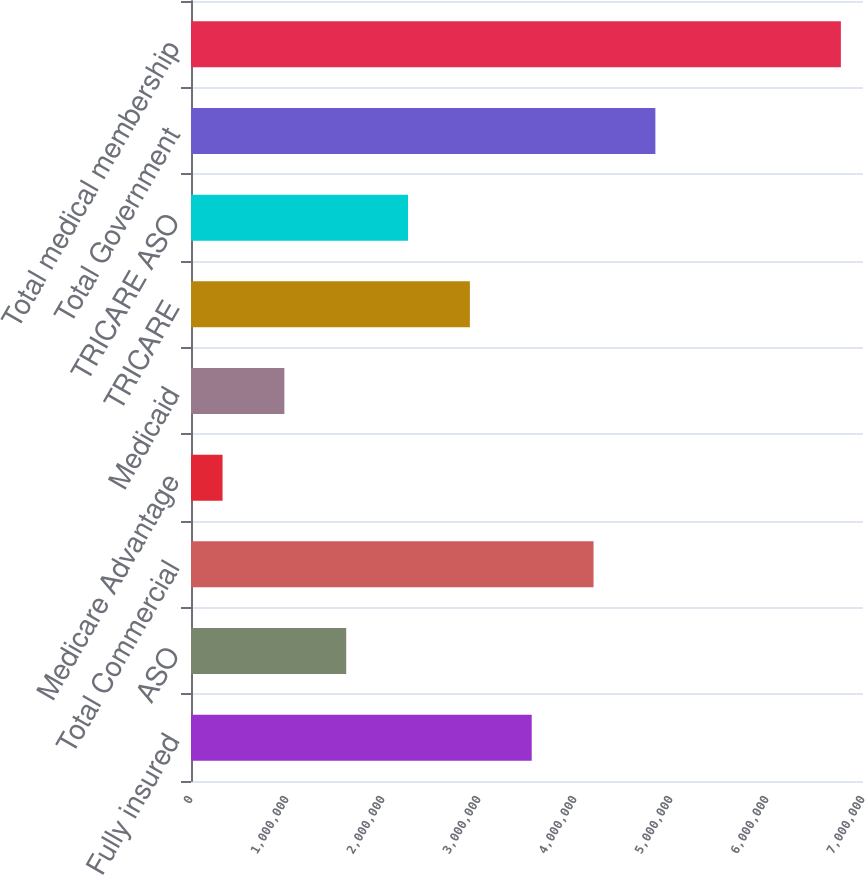Convert chart to OTSL. <chart><loc_0><loc_0><loc_500><loc_500><bar_chart><fcel>Fully insured<fcel>ASO<fcel>Total Commercial<fcel>Medicare Advantage<fcel>Medicaid<fcel>TRICARE<fcel>TRICARE ASO<fcel>Total Government<fcel>Total medical membership<nl><fcel>3.5491e+06<fcel>1.6168e+06<fcel>4.1932e+06<fcel>328600<fcel>972700<fcel>2.905e+06<fcel>2.2609e+06<fcel>4.8373e+06<fcel>6.7696e+06<nl></chart> 